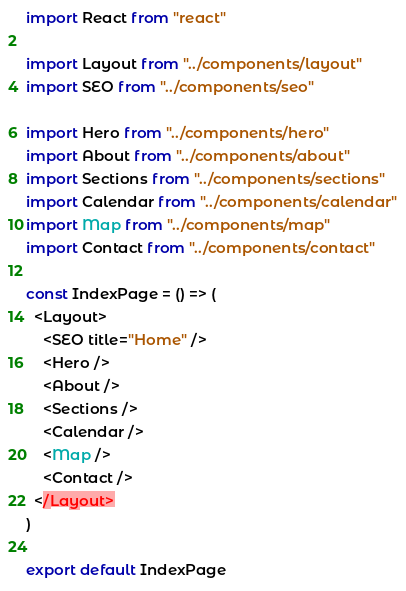<code> <loc_0><loc_0><loc_500><loc_500><_JavaScript_>import React from "react"

import Layout from "../components/layout"
import SEO from "../components/seo"

import Hero from "../components/hero"
import About from "../components/about"
import Sections from "../components/sections"
import Calendar from "../components/calendar"
import Map from "../components/map"
import Contact from "../components/contact"

const IndexPage = () => (
  <Layout>
    <SEO title="Home" />
    <Hero />
    <About />
    <Sections />
    <Calendar />
    <Map />
    <Contact />
  </Layout>
)

export default IndexPage
</code> 